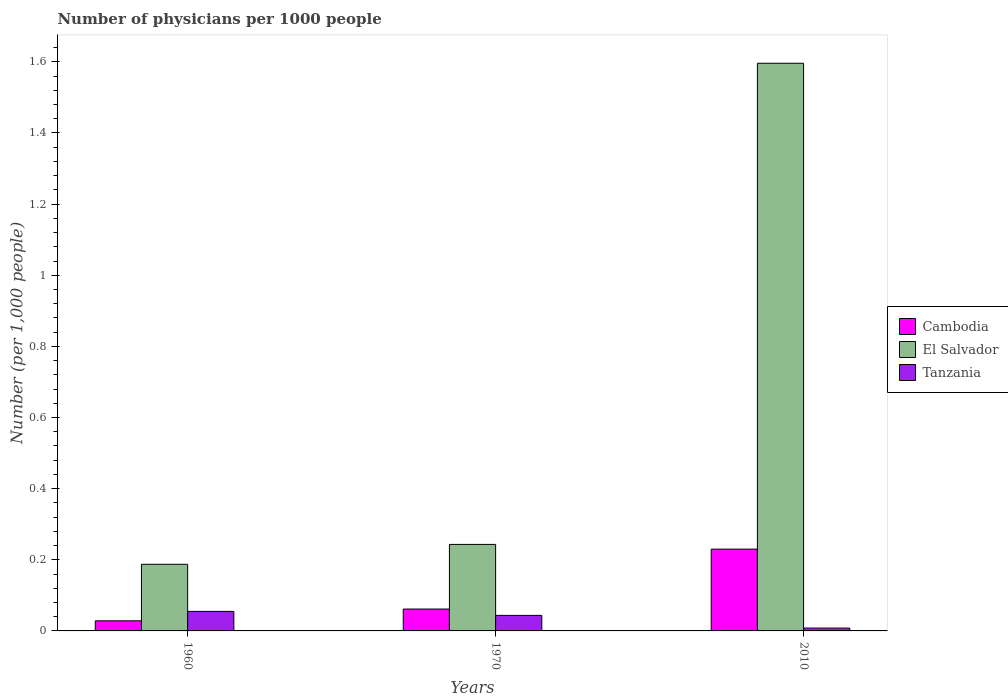Are the number of bars on each tick of the X-axis equal?
Make the answer very short. Yes. How many bars are there on the 2nd tick from the left?
Give a very brief answer. 3. What is the label of the 3rd group of bars from the left?
Offer a very short reply. 2010. In how many cases, is the number of bars for a given year not equal to the number of legend labels?
Ensure brevity in your answer.  0. What is the number of physicians in El Salvador in 1960?
Your response must be concise. 0.19. Across all years, what is the maximum number of physicians in El Salvador?
Provide a succinct answer. 1.6. Across all years, what is the minimum number of physicians in El Salvador?
Offer a very short reply. 0.19. In which year was the number of physicians in Tanzania minimum?
Keep it short and to the point. 2010. What is the total number of physicians in El Salvador in the graph?
Your answer should be very brief. 2.03. What is the difference between the number of physicians in Cambodia in 1960 and that in 2010?
Offer a terse response. -0.2. What is the difference between the number of physicians in Cambodia in 2010 and the number of physicians in El Salvador in 1960?
Your response must be concise. 0.04. What is the average number of physicians in El Salvador per year?
Offer a very short reply. 0.68. In the year 2010, what is the difference between the number of physicians in El Salvador and number of physicians in Cambodia?
Your answer should be very brief. 1.37. In how many years, is the number of physicians in Cambodia greater than 0.56?
Keep it short and to the point. 0. What is the ratio of the number of physicians in Tanzania in 1960 to that in 2010?
Ensure brevity in your answer.  6.86. Is the difference between the number of physicians in El Salvador in 1960 and 1970 greater than the difference between the number of physicians in Cambodia in 1960 and 1970?
Your answer should be compact. No. What is the difference between the highest and the second highest number of physicians in El Salvador?
Offer a very short reply. 1.35. What is the difference between the highest and the lowest number of physicians in El Salvador?
Your answer should be compact. 1.41. In how many years, is the number of physicians in El Salvador greater than the average number of physicians in El Salvador taken over all years?
Your response must be concise. 1. What does the 3rd bar from the left in 1960 represents?
Give a very brief answer. Tanzania. What does the 3rd bar from the right in 1960 represents?
Your answer should be very brief. Cambodia. How many bars are there?
Keep it short and to the point. 9. Does the graph contain any zero values?
Provide a succinct answer. No. How are the legend labels stacked?
Provide a succinct answer. Vertical. What is the title of the graph?
Your answer should be compact. Number of physicians per 1000 people. Does "France" appear as one of the legend labels in the graph?
Offer a very short reply. No. What is the label or title of the X-axis?
Make the answer very short. Years. What is the label or title of the Y-axis?
Ensure brevity in your answer.  Number (per 1,0 people). What is the Number (per 1,000 people) of Cambodia in 1960?
Provide a short and direct response. 0.03. What is the Number (per 1,000 people) of El Salvador in 1960?
Provide a succinct answer. 0.19. What is the Number (per 1,000 people) of Tanzania in 1960?
Keep it short and to the point. 0.05. What is the Number (per 1,000 people) of Cambodia in 1970?
Ensure brevity in your answer.  0.06. What is the Number (per 1,000 people) in El Salvador in 1970?
Keep it short and to the point. 0.24. What is the Number (per 1,000 people) in Tanzania in 1970?
Provide a succinct answer. 0.04. What is the Number (per 1,000 people) of Cambodia in 2010?
Your response must be concise. 0.23. What is the Number (per 1,000 people) of El Salvador in 2010?
Your response must be concise. 1.6. What is the Number (per 1,000 people) in Tanzania in 2010?
Your answer should be compact. 0.01. Across all years, what is the maximum Number (per 1,000 people) of Cambodia?
Your answer should be compact. 0.23. Across all years, what is the maximum Number (per 1,000 people) of El Salvador?
Provide a short and direct response. 1.6. Across all years, what is the maximum Number (per 1,000 people) of Tanzania?
Make the answer very short. 0.05. Across all years, what is the minimum Number (per 1,000 people) in Cambodia?
Provide a short and direct response. 0.03. Across all years, what is the minimum Number (per 1,000 people) in El Salvador?
Your response must be concise. 0.19. Across all years, what is the minimum Number (per 1,000 people) of Tanzania?
Provide a succinct answer. 0.01. What is the total Number (per 1,000 people) in Cambodia in the graph?
Your answer should be compact. 0.32. What is the total Number (per 1,000 people) of El Salvador in the graph?
Make the answer very short. 2.03. What is the total Number (per 1,000 people) in Tanzania in the graph?
Offer a very short reply. 0.11. What is the difference between the Number (per 1,000 people) in Cambodia in 1960 and that in 1970?
Your answer should be compact. -0.03. What is the difference between the Number (per 1,000 people) of El Salvador in 1960 and that in 1970?
Ensure brevity in your answer.  -0.06. What is the difference between the Number (per 1,000 people) of Tanzania in 1960 and that in 1970?
Give a very brief answer. 0.01. What is the difference between the Number (per 1,000 people) of Cambodia in 1960 and that in 2010?
Give a very brief answer. -0.2. What is the difference between the Number (per 1,000 people) in El Salvador in 1960 and that in 2010?
Your answer should be compact. -1.41. What is the difference between the Number (per 1,000 people) in Tanzania in 1960 and that in 2010?
Provide a short and direct response. 0.05. What is the difference between the Number (per 1,000 people) in Cambodia in 1970 and that in 2010?
Provide a succinct answer. -0.17. What is the difference between the Number (per 1,000 people) in El Salvador in 1970 and that in 2010?
Your answer should be compact. -1.35. What is the difference between the Number (per 1,000 people) in Tanzania in 1970 and that in 2010?
Ensure brevity in your answer.  0.04. What is the difference between the Number (per 1,000 people) in Cambodia in 1960 and the Number (per 1,000 people) in El Salvador in 1970?
Provide a short and direct response. -0.21. What is the difference between the Number (per 1,000 people) in Cambodia in 1960 and the Number (per 1,000 people) in Tanzania in 1970?
Offer a terse response. -0.02. What is the difference between the Number (per 1,000 people) of El Salvador in 1960 and the Number (per 1,000 people) of Tanzania in 1970?
Keep it short and to the point. 0.14. What is the difference between the Number (per 1,000 people) of Cambodia in 1960 and the Number (per 1,000 people) of El Salvador in 2010?
Provide a short and direct response. -1.57. What is the difference between the Number (per 1,000 people) of Cambodia in 1960 and the Number (per 1,000 people) of Tanzania in 2010?
Provide a succinct answer. 0.02. What is the difference between the Number (per 1,000 people) of El Salvador in 1960 and the Number (per 1,000 people) of Tanzania in 2010?
Your answer should be very brief. 0.18. What is the difference between the Number (per 1,000 people) in Cambodia in 1970 and the Number (per 1,000 people) in El Salvador in 2010?
Offer a very short reply. -1.53. What is the difference between the Number (per 1,000 people) of Cambodia in 1970 and the Number (per 1,000 people) of Tanzania in 2010?
Your answer should be very brief. 0.05. What is the difference between the Number (per 1,000 people) of El Salvador in 1970 and the Number (per 1,000 people) of Tanzania in 2010?
Ensure brevity in your answer.  0.24. What is the average Number (per 1,000 people) of Cambodia per year?
Your answer should be compact. 0.11. What is the average Number (per 1,000 people) in El Salvador per year?
Your answer should be compact. 0.68. What is the average Number (per 1,000 people) in Tanzania per year?
Your response must be concise. 0.04. In the year 1960, what is the difference between the Number (per 1,000 people) of Cambodia and Number (per 1,000 people) of El Salvador?
Ensure brevity in your answer.  -0.16. In the year 1960, what is the difference between the Number (per 1,000 people) of Cambodia and Number (per 1,000 people) of Tanzania?
Offer a terse response. -0.03. In the year 1960, what is the difference between the Number (per 1,000 people) in El Salvador and Number (per 1,000 people) in Tanzania?
Keep it short and to the point. 0.13. In the year 1970, what is the difference between the Number (per 1,000 people) in Cambodia and Number (per 1,000 people) in El Salvador?
Keep it short and to the point. -0.18. In the year 1970, what is the difference between the Number (per 1,000 people) in Cambodia and Number (per 1,000 people) in Tanzania?
Your response must be concise. 0.02. In the year 1970, what is the difference between the Number (per 1,000 people) in El Salvador and Number (per 1,000 people) in Tanzania?
Ensure brevity in your answer.  0.2. In the year 2010, what is the difference between the Number (per 1,000 people) of Cambodia and Number (per 1,000 people) of El Salvador?
Ensure brevity in your answer.  -1.37. In the year 2010, what is the difference between the Number (per 1,000 people) in Cambodia and Number (per 1,000 people) in Tanzania?
Provide a short and direct response. 0.22. In the year 2010, what is the difference between the Number (per 1,000 people) of El Salvador and Number (per 1,000 people) of Tanzania?
Provide a short and direct response. 1.59. What is the ratio of the Number (per 1,000 people) of Cambodia in 1960 to that in 1970?
Your response must be concise. 0.46. What is the ratio of the Number (per 1,000 people) in El Salvador in 1960 to that in 1970?
Keep it short and to the point. 0.77. What is the ratio of the Number (per 1,000 people) of Tanzania in 1960 to that in 1970?
Your response must be concise. 1.26. What is the ratio of the Number (per 1,000 people) of Cambodia in 1960 to that in 2010?
Provide a succinct answer. 0.12. What is the ratio of the Number (per 1,000 people) in El Salvador in 1960 to that in 2010?
Ensure brevity in your answer.  0.12. What is the ratio of the Number (per 1,000 people) in Tanzania in 1960 to that in 2010?
Your response must be concise. 6.86. What is the ratio of the Number (per 1,000 people) in Cambodia in 1970 to that in 2010?
Make the answer very short. 0.27. What is the ratio of the Number (per 1,000 people) in El Salvador in 1970 to that in 2010?
Keep it short and to the point. 0.15. What is the ratio of the Number (per 1,000 people) of Tanzania in 1970 to that in 2010?
Ensure brevity in your answer.  5.46. What is the difference between the highest and the second highest Number (per 1,000 people) in Cambodia?
Ensure brevity in your answer.  0.17. What is the difference between the highest and the second highest Number (per 1,000 people) in El Salvador?
Your response must be concise. 1.35. What is the difference between the highest and the second highest Number (per 1,000 people) in Tanzania?
Your response must be concise. 0.01. What is the difference between the highest and the lowest Number (per 1,000 people) of Cambodia?
Provide a short and direct response. 0.2. What is the difference between the highest and the lowest Number (per 1,000 people) of El Salvador?
Offer a terse response. 1.41. What is the difference between the highest and the lowest Number (per 1,000 people) of Tanzania?
Offer a very short reply. 0.05. 